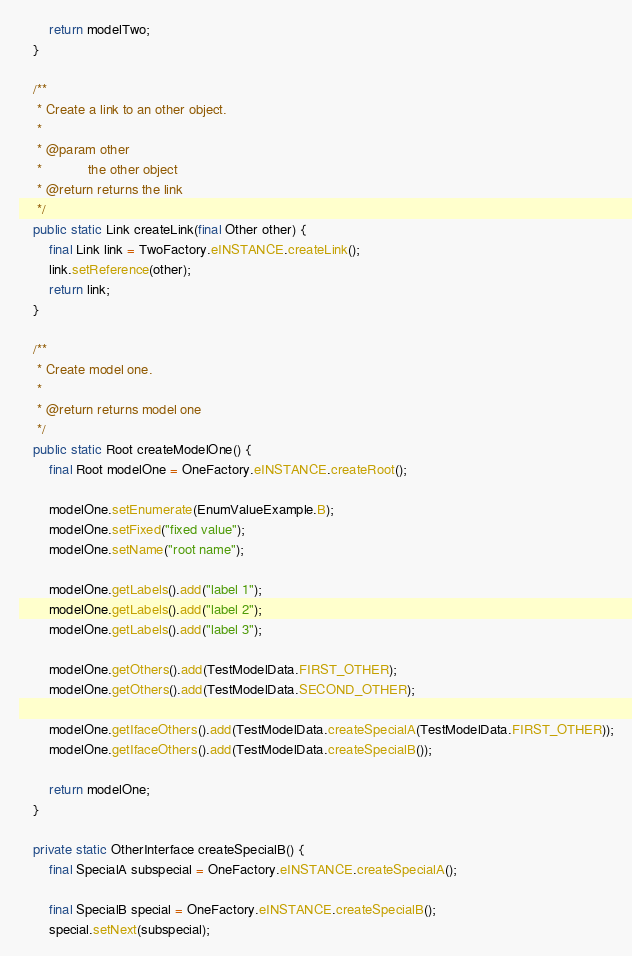<code> <loc_0><loc_0><loc_500><loc_500><_Java_>
        return modelTwo;
    }

    /**
     * Create a link to an other object.
     * 
     * @param other
     *            the other object
     * @return returns the link
     */
    public static Link createLink(final Other other) {
        final Link link = TwoFactory.eINSTANCE.createLink();
        link.setReference(other);
        return link;
    }

    /**
     * Create model one.
     *
     * @return returns model one
     */
    public static Root createModelOne() {
        final Root modelOne = OneFactory.eINSTANCE.createRoot();

        modelOne.setEnumerate(EnumValueExample.B);
        modelOne.setFixed("fixed value");
        modelOne.setName("root name");

        modelOne.getLabels().add("label 1");
        modelOne.getLabels().add("label 2");
        modelOne.getLabels().add("label 3");

        modelOne.getOthers().add(TestModelData.FIRST_OTHER);
        modelOne.getOthers().add(TestModelData.SECOND_OTHER);

        modelOne.getIfaceOthers().add(TestModelData.createSpecialA(TestModelData.FIRST_OTHER));
        modelOne.getIfaceOthers().add(TestModelData.createSpecialB());

        return modelOne;
    }

    private static OtherInterface createSpecialB() {
        final SpecialA subspecial = OneFactory.eINSTANCE.createSpecialA();

        final SpecialB special = OneFactory.eINSTANCE.createSpecialB();
        special.setNext(subspecial);</code> 